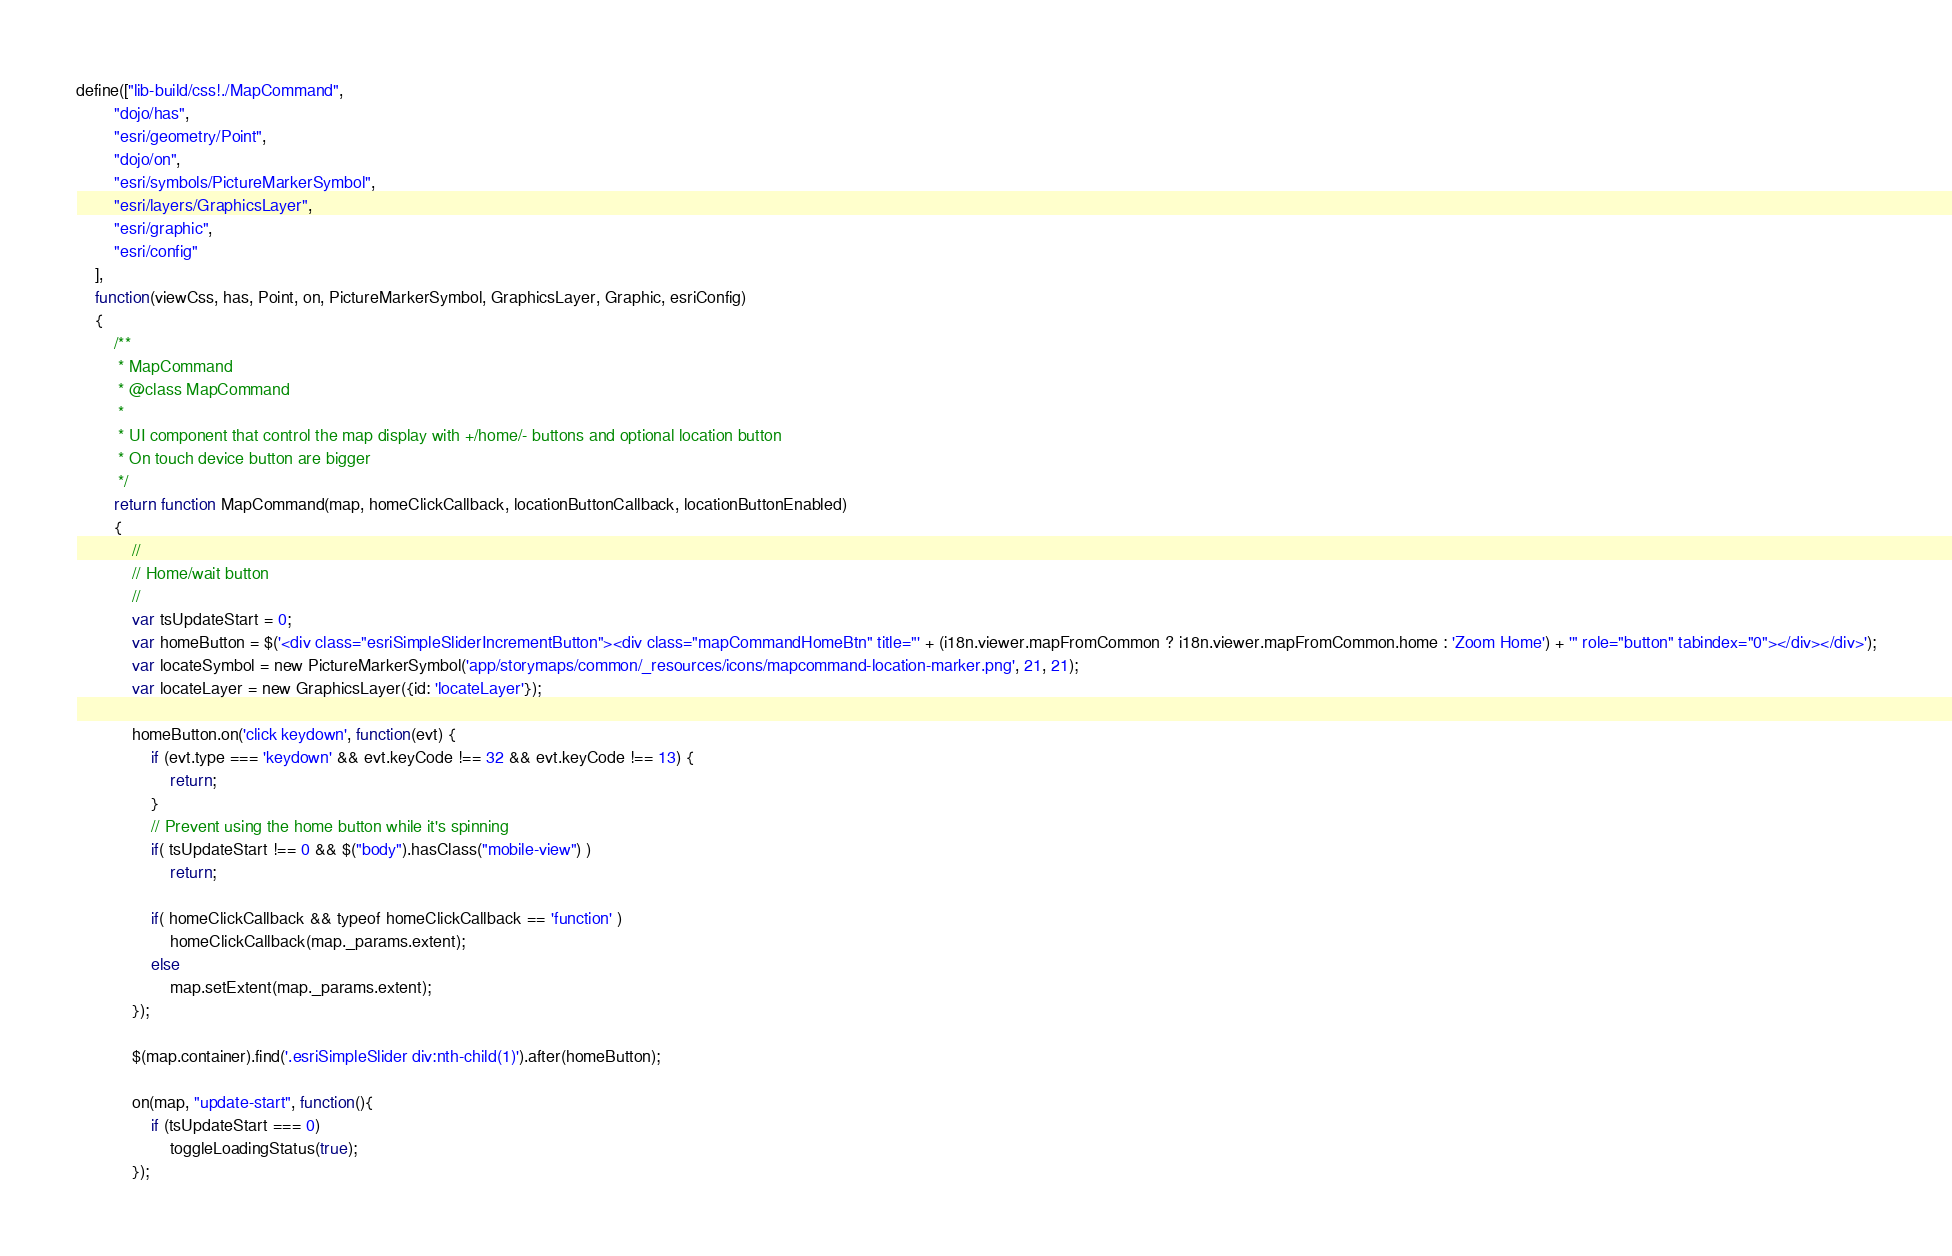Convert code to text. <code><loc_0><loc_0><loc_500><loc_500><_JavaScript_>define(["lib-build/css!./MapCommand",
		"dojo/has",
		"esri/geometry/Point",
		"dojo/on",
		"esri/symbols/PictureMarkerSymbol",
		"esri/layers/GraphicsLayer",
		"esri/graphic",
		"esri/config"
	],
	function(viewCss, has, Point, on, PictureMarkerSymbol, GraphicsLayer, Graphic, esriConfig)
	{
		/**
		 * MapCommand
		 * @class MapCommand
		 *
		 * UI component that control the map display with +/home/- buttons and optional location button
		 * On touch device button are bigger
		 */
		return function MapCommand(map, homeClickCallback, locationButtonCallback, locationButtonEnabled)
		{
			//
			// Home/wait button
			//
			var tsUpdateStart = 0;
			var homeButton = $('<div class="esriSimpleSliderIncrementButton"><div class="mapCommandHomeBtn" title="' + (i18n.viewer.mapFromCommon ? i18n.viewer.mapFromCommon.home : 'Zoom Home') + '" role="button" tabindex="0"></div></div>');
			var locateSymbol = new PictureMarkerSymbol('app/storymaps/common/_resources/icons/mapcommand-location-marker.png', 21, 21);
			var locateLayer = new GraphicsLayer({id: 'locateLayer'});

			homeButton.on('click keydown', function(evt) {
				if (evt.type === 'keydown' && evt.keyCode !== 32 && evt.keyCode !== 13) {
					return;
				}
				// Prevent using the home button while it's spinning
				if( tsUpdateStart !== 0 && $("body").hasClass("mobile-view") )
					return;

				if( homeClickCallback && typeof homeClickCallback == 'function' )
					homeClickCallback(map._params.extent);
				else
					map.setExtent(map._params.extent);
			});

			$(map.container).find('.esriSimpleSlider div:nth-child(1)').after(homeButton);

			on(map, "update-start", function(){
				if (tsUpdateStart === 0)
					toggleLoadingStatus(true);
			});
</code> 